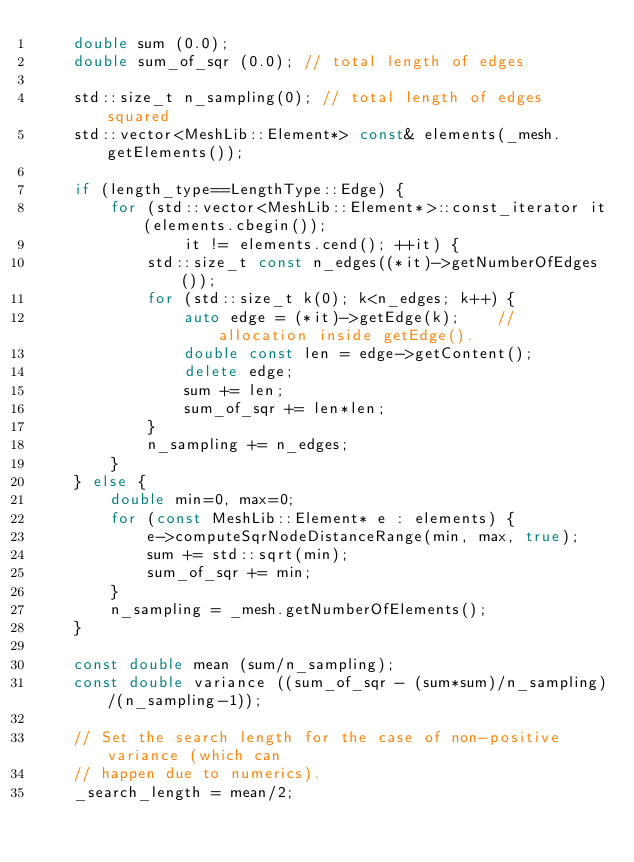Convert code to text. <code><loc_0><loc_0><loc_500><loc_500><_C++_>    double sum (0.0);
    double sum_of_sqr (0.0); // total length of edges

    std::size_t n_sampling(0); // total length of edges squared
    std::vector<MeshLib::Element*> const& elements(_mesh.getElements());

    if (length_type==LengthType::Edge) {
        for (std::vector<MeshLib::Element*>::const_iterator it(elements.cbegin());
                it != elements.cend(); ++it) {
            std::size_t const n_edges((*it)->getNumberOfEdges());
            for (std::size_t k(0); k<n_edges; k++) {
                auto edge = (*it)->getEdge(k);    // allocation inside getEdge().
                double const len = edge->getContent();
                delete edge;
                sum += len;
                sum_of_sqr += len*len;
            }
            n_sampling += n_edges;
        }
    } else {
        double min=0, max=0;
        for (const MeshLib::Element* e : elements) {
            e->computeSqrNodeDistanceRange(min, max, true);
            sum += std::sqrt(min);
            sum_of_sqr += min;
        }
        n_sampling = _mesh.getNumberOfElements();
    }

    const double mean (sum/n_sampling);
    const double variance ((sum_of_sqr - (sum*sum)/n_sampling)/(n_sampling-1));

    // Set the search length for the case of non-positive variance (which can
    // happen due to numerics).
    _search_length = mean/2;
</code> 